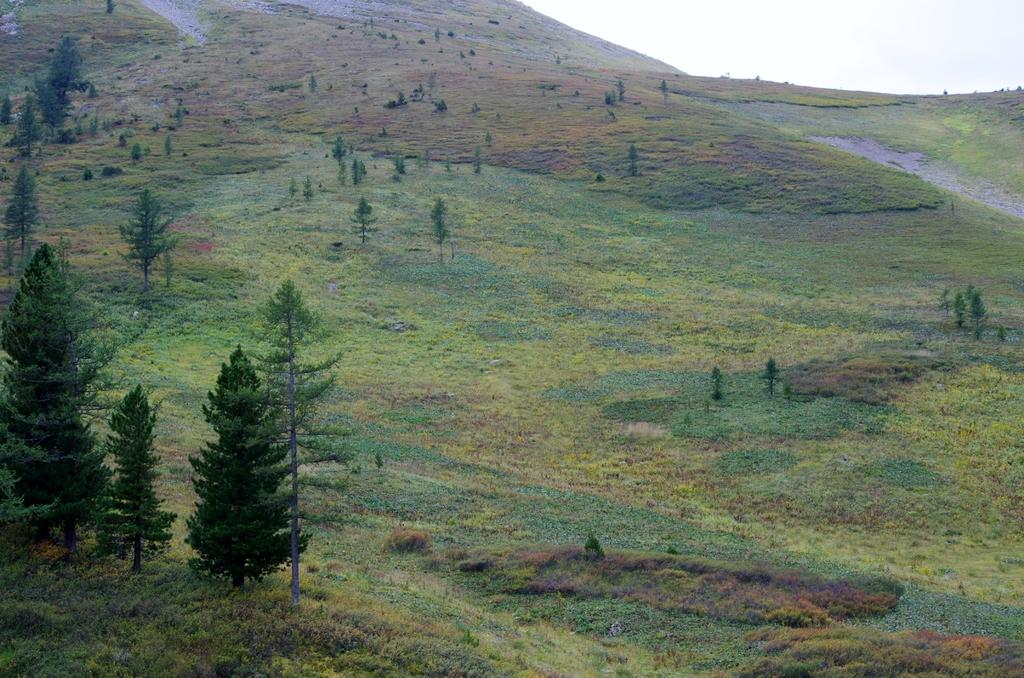What type of surface can be seen in the image? The ground is visible in the image. What type of vegetation is present on the ground? There is grass in the image. What other types of vegetation can be seen in the image? There are plants and trees in the image. What is visible above the vegetation in the image? The sky is visible in the image. How does the digestion process work for the plants in the image? The image does not provide information about the digestion process of the plants; it only shows their appearance. 